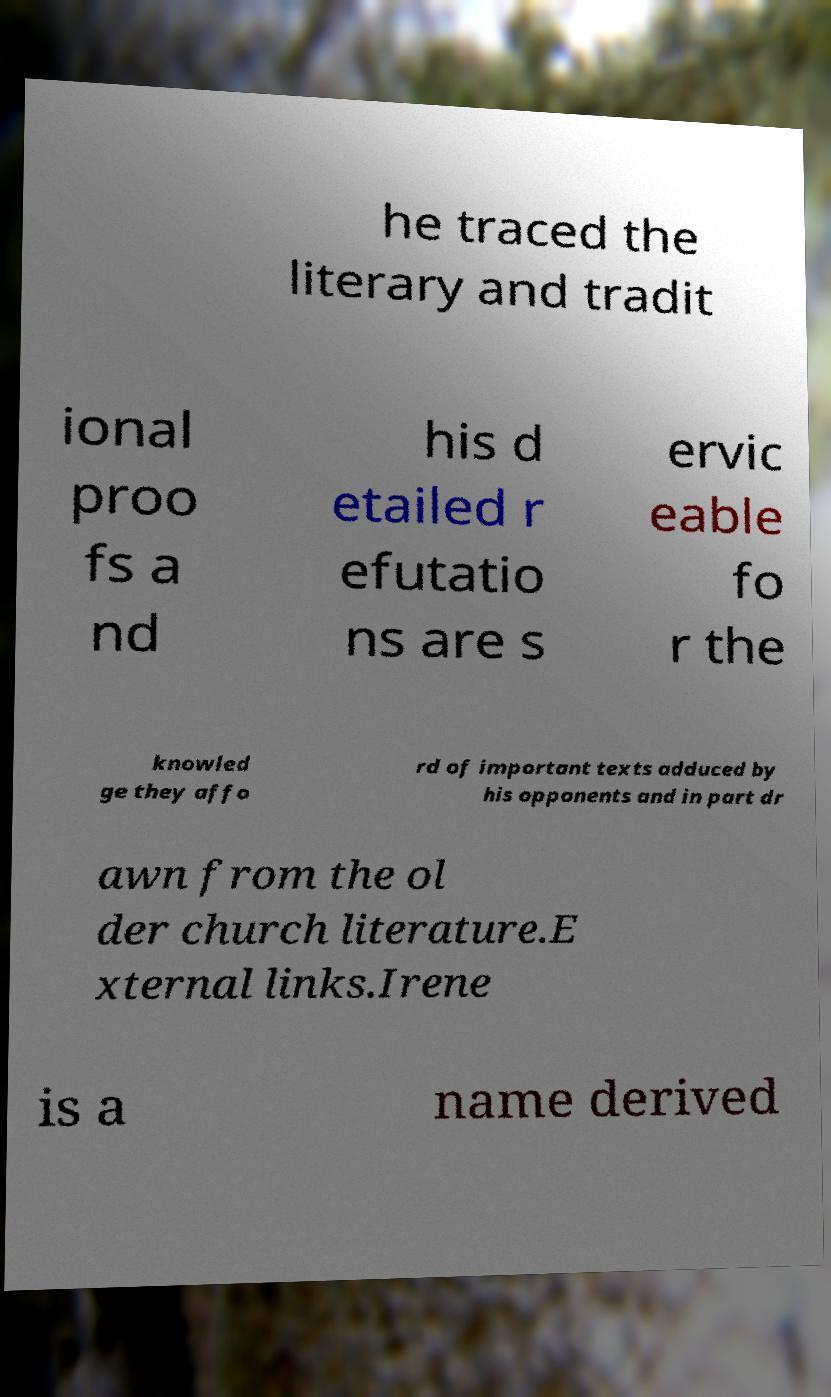Please identify and transcribe the text found in this image. he traced the literary and tradit ional proo fs a nd his d etailed r efutatio ns are s ervic eable fo r the knowled ge they affo rd of important texts adduced by his opponents and in part dr awn from the ol der church literature.E xternal links.Irene is a name derived 